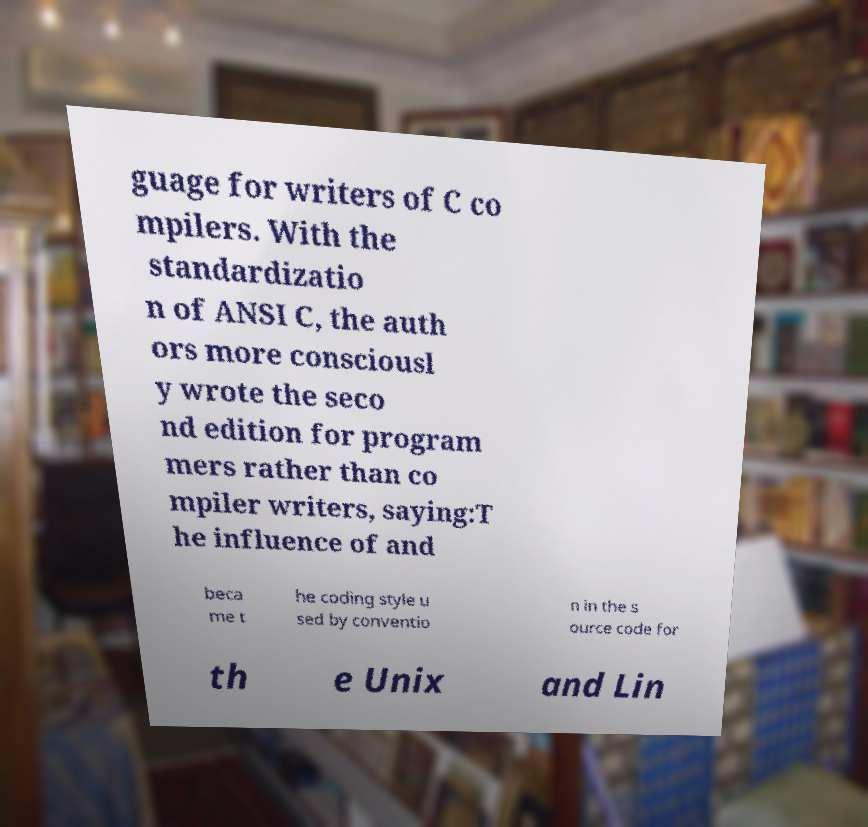There's text embedded in this image that I need extracted. Can you transcribe it verbatim? guage for writers of C co mpilers. With the standardizatio n of ANSI C, the auth ors more consciousl y wrote the seco nd edition for program mers rather than co mpiler writers, saying:T he influence of and beca me t he coding style u sed by conventio n in the s ource code for th e Unix and Lin 